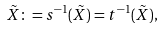<formula> <loc_0><loc_0><loc_500><loc_500>\tilde { X } \colon = s ^ { - 1 } ( \tilde { X } ) = t ^ { - 1 } ( \tilde { X } ) ,</formula> 